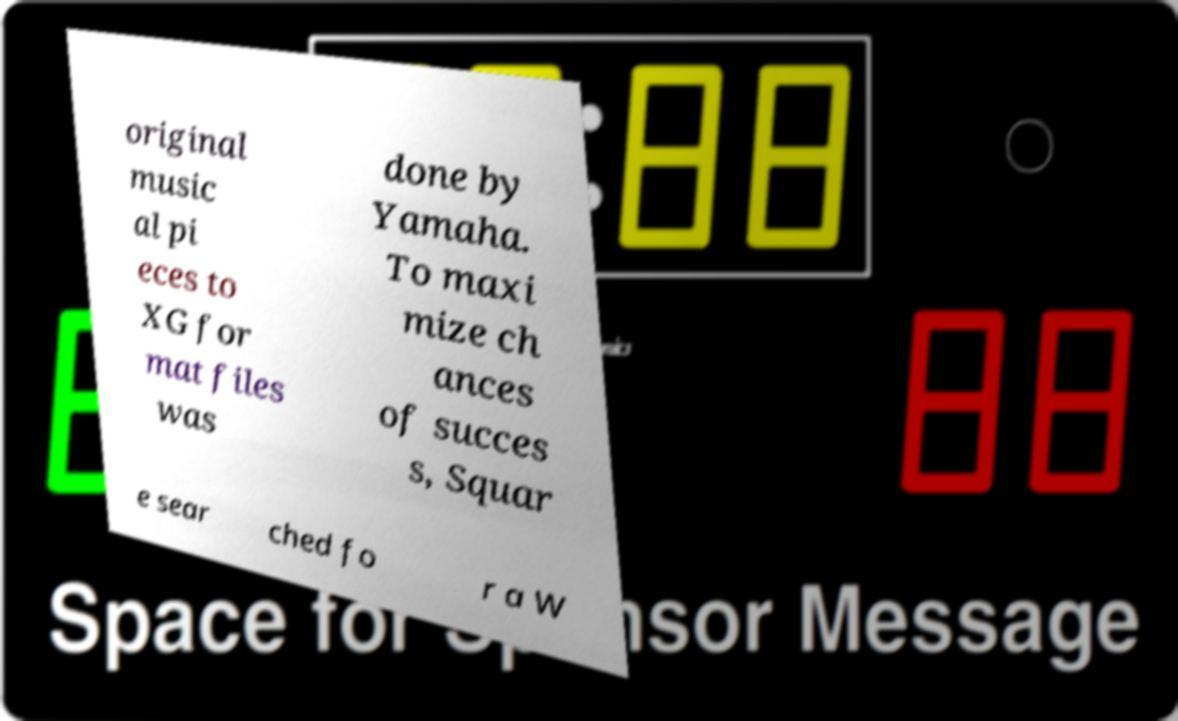Can you accurately transcribe the text from the provided image for me? original music al pi eces to XG for mat files was done by Yamaha. To maxi mize ch ances of succes s, Squar e sear ched fo r a W 